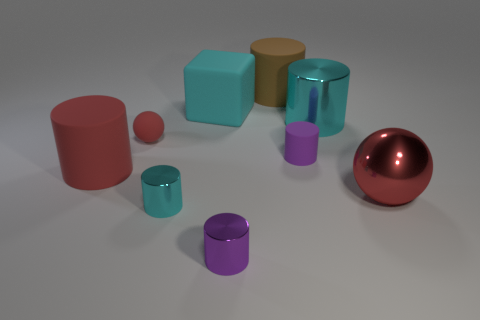Subtract all red cylinders. How many cylinders are left? 5 Add 1 small rubber cylinders. How many objects exist? 10 Subtract all red cylinders. How many cylinders are left? 5 Subtract all spheres. How many objects are left? 7 Subtract 6 cylinders. How many cylinders are left? 0 Subtract all yellow cylinders. Subtract all red blocks. How many cylinders are left? 6 Subtract all yellow balls. How many blue cylinders are left? 0 Subtract all small rubber objects. Subtract all small purple matte objects. How many objects are left? 6 Add 1 big objects. How many big objects are left? 6 Add 3 red matte cylinders. How many red matte cylinders exist? 4 